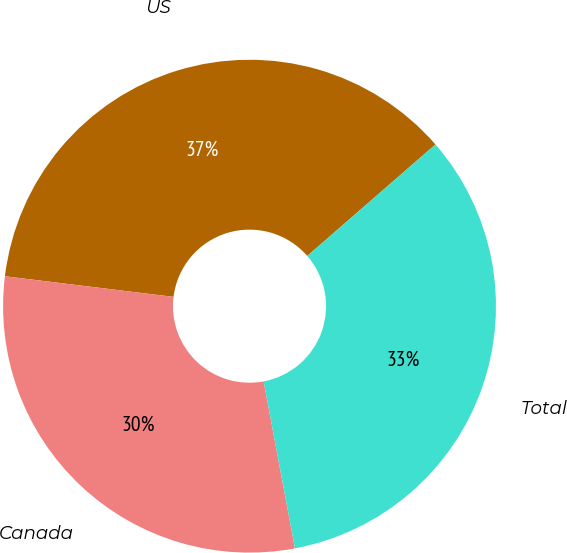<chart> <loc_0><loc_0><loc_500><loc_500><pie_chart><fcel>US<fcel>Canada<fcel>Total<nl><fcel>36.67%<fcel>29.89%<fcel>33.44%<nl></chart> 